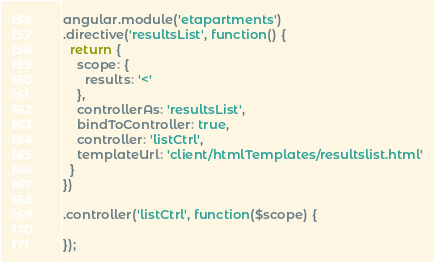<code> <loc_0><loc_0><loc_500><loc_500><_JavaScript_>angular.module('etapartments')
.directive('resultsList', function() {
  return {
    scope: {
      results: '<'
    },
    controllerAs: 'resultsList',
    bindToController: true,
    controller: 'listCtrl',
    templateUrl: 'client/htmlTemplates/resultslist.html'
  }
})

.controller('listCtrl', function($scope) {

});</code> 